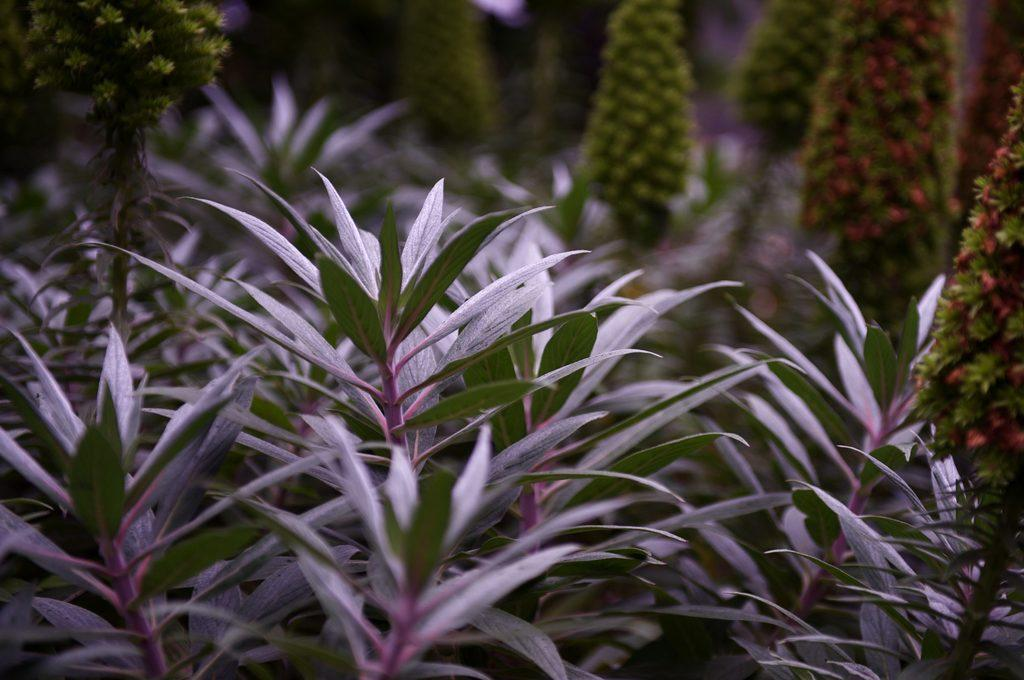What types of plants can be seen in the image? There are plants in the foreground and background of the image. Can you describe the plants in the foreground? Unfortunately, the facts provided do not give specific details about the plants in the foreground. How many different types of plants are visible in the image? The facts provided only mention that there are plants in the foreground and background, so it is not possible to determine the exact number of different types of plants. What caption would best describe the love between the two plants in the image? There are no captions or any indication of love between plants in the image, as it only features plants in the foreground and background. 